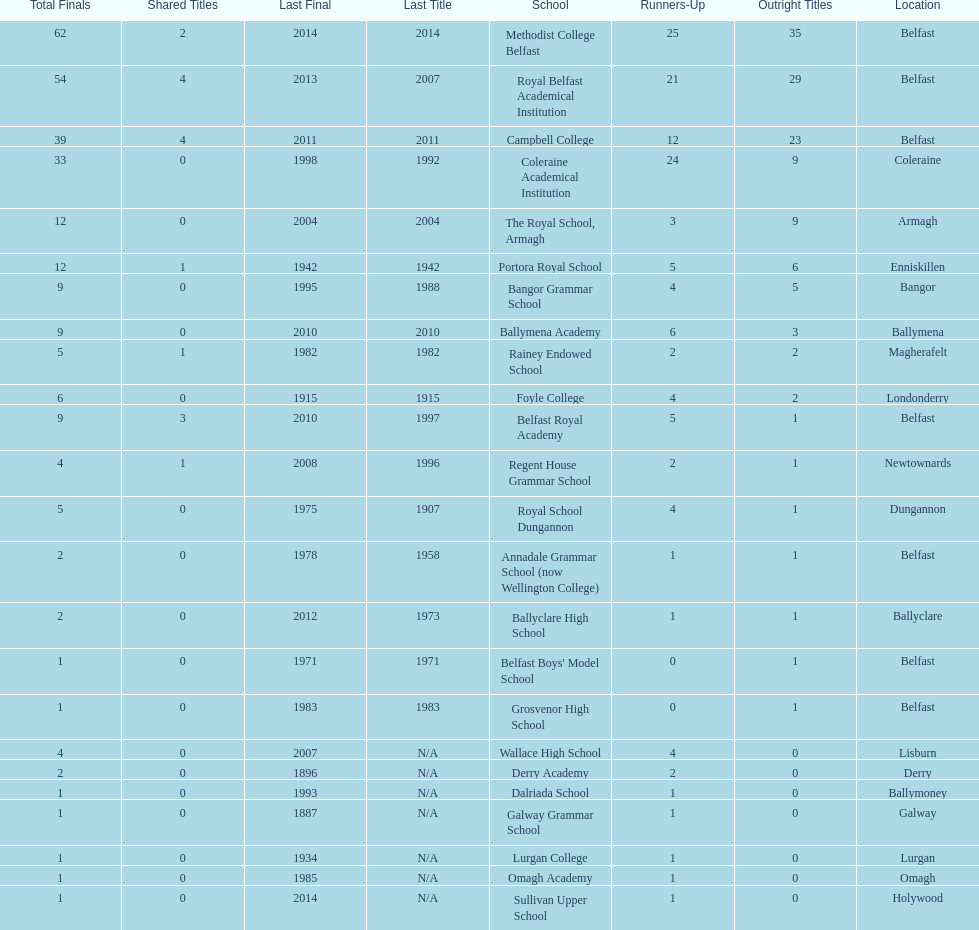How many educational institutions have experienced 3 or more shared title wins? 3. 